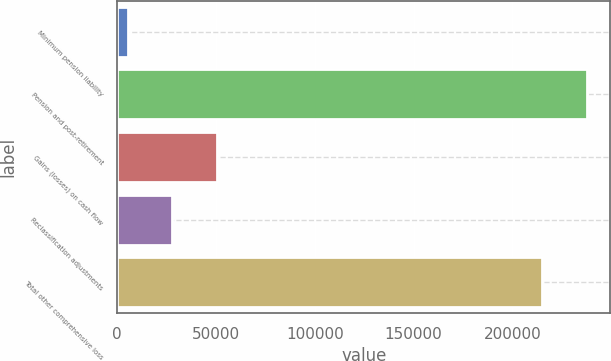Convert chart. <chart><loc_0><loc_0><loc_500><loc_500><bar_chart><fcel>Minimum pension liability<fcel>Pension and post-retirement<fcel>Gains (losses) on cash flow<fcel>Reclassification adjustments<fcel>Total other comprehensive loss<nl><fcel>5395<fcel>237694<fcel>50350<fcel>27872.5<fcel>215217<nl></chart> 